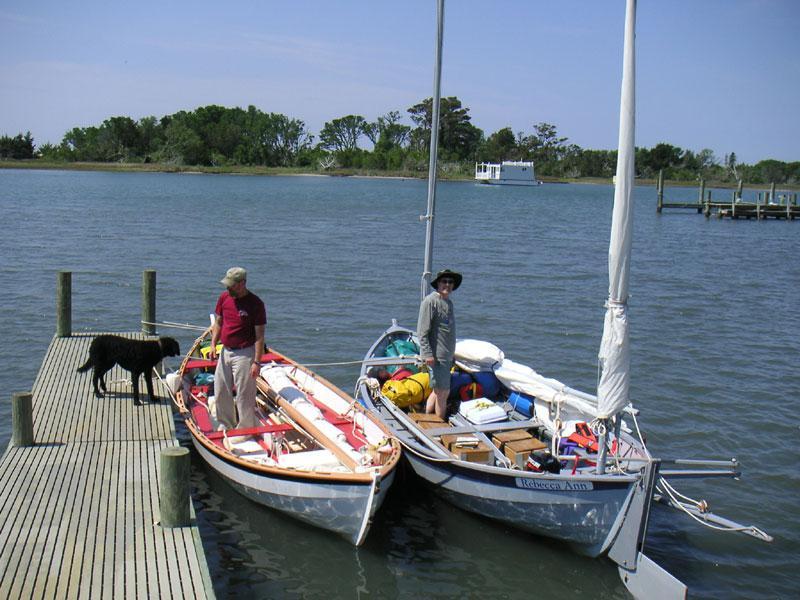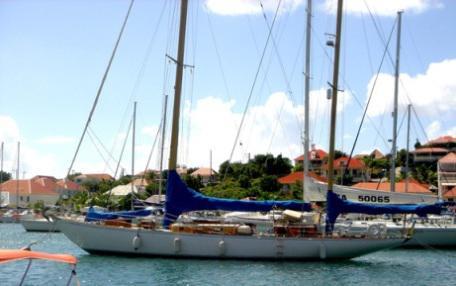The first image is the image on the left, the second image is the image on the right. Examine the images to the left and right. Is the description "People are in two sailboats in the water in one of the images." accurate? Answer yes or no. Yes. The first image is the image on the left, the second image is the image on the right. For the images shown, is this caption "One image shows at least one sailboat with unfurled sails, and the other image shows a boat with furled sails that is not next to a dock." true? Answer yes or no. No. 